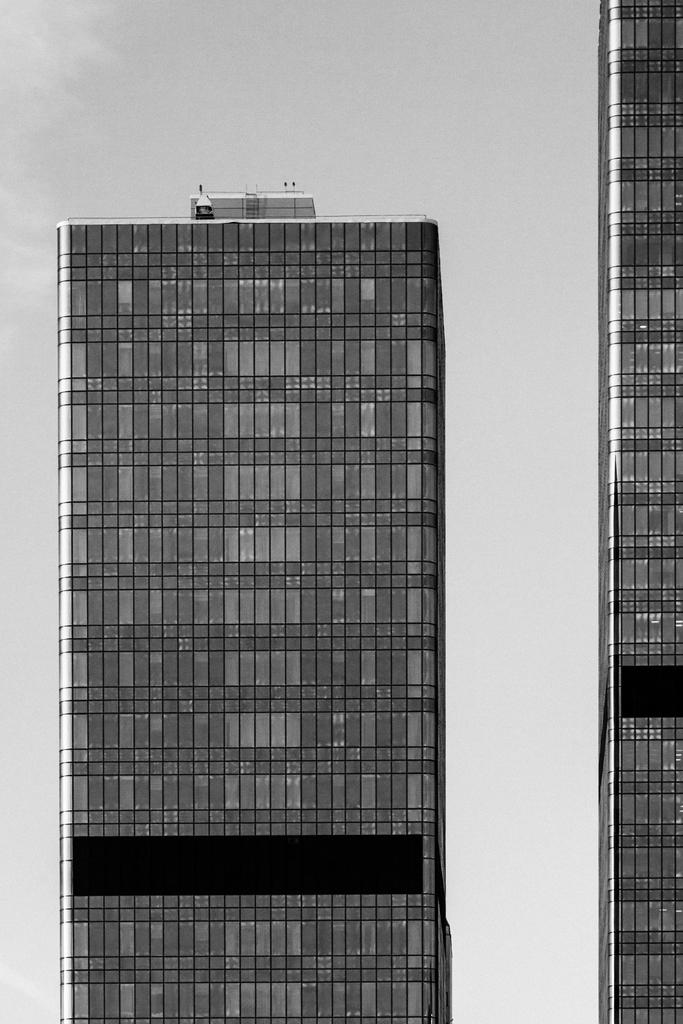What is the color scheme of the image? The image is black and white. How many buildings can be seen in the image? There are two buildings in the image. How many apples are on the roof of the building in the image? There are no apples present in the image, as it is a black and white image of two buildings. What are the cats doing in the image? There are no cats present in the image; it features two black and white buildings. 